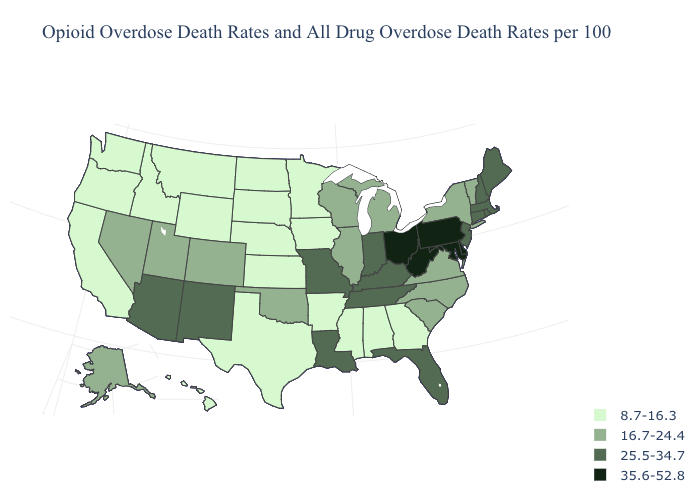What is the value of Alaska?
Concise answer only. 16.7-24.4. What is the value of Connecticut?
Write a very short answer. 25.5-34.7. Does Connecticut have the highest value in the Northeast?
Be succinct. No. Does Hawaii have the lowest value in the USA?
Quick response, please. Yes. Does the map have missing data?
Short answer required. No. Name the states that have a value in the range 8.7-16.3?
Be succinct. Alabama, Arkansas, California, Georgia, Hawaii, Idaho, Iowa, Kansas, Minnesota, Mississippi, Montana, Nebraska, North Dakota, Oregon, South Dakota, Texas, Washington, Wyoming. Name the states that have a value in the range 8.7-16.3?
Write a very short answer. Alabama, Arkansas, California, Georgia, Hawaii, Idaho, Iowa, Kansas, Minnesota, Mississippi, Montana, Nebraska, North Dakota, Oregon, South Dakota, Texas, Washington, Wyoming. Does Indiana have a lower value than California?
Give a very brief answer. No. Does Delaware have the highest value in the USA?
Answer briefly. Yes. What is the highest value in the MidWest ?
Answer briefly. 35.6-52.8. Among the states that border New Hampshire , which have the highest value?
Concise answer only. Maine, Massachusetts. What is the value of New Mexico?
Be succinct. 25.5-34.7. Name the states that have a value in the range 35.6-52.8?
Short answer required. Delaware, Maryland, Ohio, Pennsylvania, West Virginia. What is the value of Vermont?
Concise answer only. 16.7-24.4. 